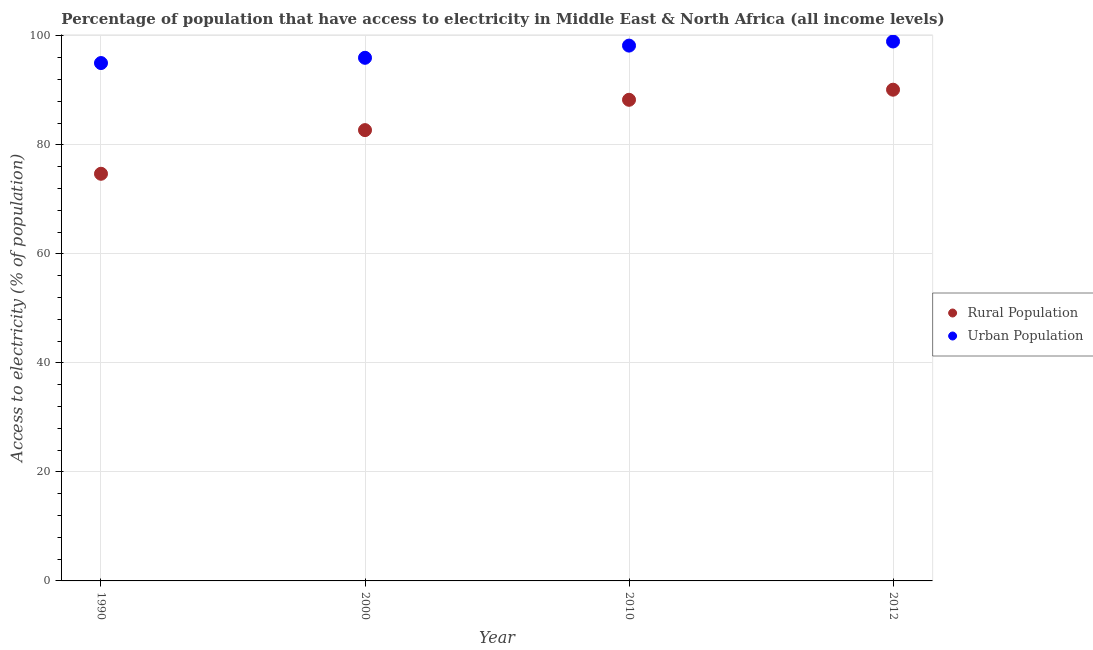How many different coloured dotlines are there?
Your answer should be compact. 2. Is the number of dotlines equal to the number of legend labels?
Provide a succinct answer. Yes. What is the percentage of urban population having access to electricity in 2012?
Offer a terse response. 98.98. Across all years, what is the maximum percentage of rural population having access to electricity?
Provide a short and direct response. 90.14. Across all years, what is the minimum percentage of rural population having access to electricity?
Ensure brevity in your answer.  74.71. In which year was the percentage of urban population having access to electricity maximum?
Keep it short and to the point. 2012. What is the total percentage of urban population having access to electricity in the graph?
Provide a succinct answer. 388.23. What is the difference between the percentage of rural population having access to electricity in 1990 and that in 2012?
Offer a very short reply. -15.43. What is the difference between the percentage of urban population having access to electricity in 2010 and the percentage of rural population having access to electricity in 2012?
Offer a very short reply. 8.09. What is the average percentage of urban population having access to electricity per year?
Give a very brief answer. 97.06. In the year 1990, what is the difference between the percentage of urban population having access to electricity and percentage of rural population having access to electricity?
Offer a terse response. 20.32. What is the ratio of the percentage of rural population having access to electricity in 2000 to that in 2012?
Offer a terse response. 0.92. What is the difference between the highest and the second highest percentage of urban population having access to electricity?
Provide a succinct answer. 0.76. What is the difference between the highest and the lowest percentage of urban population having access to electricity?
Give a very brief answer. 3.96. In how many years, is the percentage of urban population having access to electricity greater than the average percentage of urban population having access to electricity taken over all years?
Keep it short and to the point. 2. Does the percentage of urban population having access to electricity monotonically increase over the years?
Your answer should be compact. Yes. Is the percentage of urban population having access to electricity strictly greater than the percentage of rural population having access to electricity over the years?
Your answer should be compact. Yes. Is the percentage of rural population having access to electricity strictly less than the percentage of urban population having access to electricity over the years?
Your answer should be compact. Yes. What is the difference between two consecutive major ticks on the Y-axis?
Your response must be concise. 20. Are the values on the major ticks of Y-axis written in scientific E-notation?
Offer a terse response. No. Does the graph contain any zero values?
Ensure brevity in your answer.  No. Does the graph contain grids?
Provide a short and direct response. Yes. What is the title of the graph?
Ensure brevity in your answer.  Percentage of population that have access to electricity in Middle East & North Africa (all income levels). Does "Foreign liabilities" appear as one of the legend labels in the graph?
Make the answer very short. No. What is the label or title of the Y-axis?
Your answer should be very brief. Access to electricity (% of population). What is the Access to electricity (% of population) of Rural Population in 1990?
Offer a very short reply. 74.71. What is the Access to electricity (% of population) in Urban Population in 1990?
Your answer should be very brief. 95.03. What is the Access to electricity (% of population) of Rural Population in 2000?
Offer a terse response. 82.72. What is the Access to electricity (% of population) of Urban Population in 2000?
Provide a short and direct response. 95.99. What is the Access to electricity (% of population) in Rural Population in 2010?
Offer a terse response. 88.28. What is the Access to electricity (% of population) in Urban Population in 2010?
Provide a short and direct response. 98.23. What is the Access to electricity (% of population) in Rural Population in 2012?
Keep it short and to the point. 90.14. What is the Access to electricity (% of population) in Urban Population in 2012?
Keep it short and to the point. 98.98. Across all years, what is the maximum Access to electricity (% of population) in Rural Population?
Your response must be concise. 90.14. Across all years, what is the maximum Access to electricity (% of population) in Urban Population?
Give a very brief answer. 98.98. Across all years, what is the minimum Access to electricity (% of population) of Rural Population?
Provide a short and direct response. 74.71. Across all years, what is the minimum Access to electricity (% of population) in Urban Population?
Your response must be concise. 95.03. What is the total Access to electricity (% of population) of Rural Population in the graph?
Provide a short and direct response. 335.85. What is the total Access to electricity (% of population) in Urban Population in the graph?
Provide a short and direct response. 388.23. What is the difference between the Access to electricity (% of population) in Rural Population in 1990 and that in 2000?
Your response must be concise. -8.01. What is the difference between the Access to electricity (% of population) of Urban Population in 1990 and that in 2000?
Keep it short and to the point. -0.96. What is the difference between the Access to electricity (% of population) in Rural Population in 1990 and that in 2010?
Your response must be concise. -13.57. What is the difference between the Access to electricity (% of population) in Urban Population in 1990 and that in 2010?
Offer a very short reply. -3.2. What is the difference between the Access to electricity (% of population) in Rural Population in 1990 and that in 2012?
Your answer should be compact. -15.43. What is the difference between the Access to electricity (% of population) in Urban Population in 1990 and that in 2012?
Ensure brevity in your answer.  -3.96. What is the difference between the Access to electricity (% of population) in Rural Population in 2000 and that in 2010?
Provide a short and direct response. -5.56. What is the difference between the Access to electricity (% of population) of Urban Population in 2000 and that in 2010?
Ensure brevity in your answer.  -2.24. What is the difference between the Access to electricity (% of population) of Rural Population in 2000 and that in 2012?
Your answer should be very brief. -7.42. What is the difference between the Access to electricity (% of population) in Urban Population in 2000 and that in 2012?
Ensure brevity in your answer.  -2.99. What is the difference between the Access to electricity (% of population) of Rural Population in 2010 and that in 2012?
Your answer should be very brief. -1.85. What is the difference between the Access to electricity (% of population) in Urban Population in 2010 and that in 2012?
Provide a succinct answer. -0.76. What is the difference between the Access to electricity (% of population) of Rural Population in 1990 and the Access to electricity (% of population) of Urban Population in 2000?
Provide a succinct answer. -21.28. What is the difference between the Access to electricity (% of population) of Rural Population in 1990 and the Access to electricity (% of population) of Urban Population in 2010?
Your response must be concise. -23.52. What is the difference between the Access to electricity (% of population) in Rural Population in 1990 and the Access to electricity (% of population) in Urban Population in 2012?
Make the answer very short. -24.27. What is the difference between the Access to electricity (% of population) in Rural Population in 2000 and the Access to electricity (% of population) in Urban Population in 2010?
Your answer should be very brief. -15.51. What is the difference between the Access to electricity (% of population) of Rural Population in 2000 and the Access to electricity (% of population) of Urban Population in 2012?
Provide a succinct answer. -16.26. What is the difference between the Access to electricity (% of population) of Rural Population in 2010 and the Access to electricity (% of population) of Urban Population in 2012?
Ensure brevity in your answer.  -10.7. What is the average Access to electricity (% of population) of Rural Population per year?
Your answer should be compact. 83.96. What is the average Access to electricity (% of population) in Urban Population per year?
Provide a short and direct response. 97.06. In the year 1990, what is the difference between the Access to electricity (% of population) of Rural Population and Access to electricity (% of population) of Urban Population?
Provide a short and direct response. -20.32. In the year 2000, what is the difference between the Access to electricity (% of population) of Rural Population and Access to electricity (% of population) of Urban Population?
Your answer should be compact. -13.27. In the year 2010, what is the difference between the Access to electricity (% of population) of Rural Population and Access to electricity (% of population) of Urban Population?
Ensure brevity in your answer.  -9.94. In the year 2012, what is the difference between the Access to electricity (% of population) of Rural Population and Access to electricity (% of population) of Urban Population?
Your answer should be compact. -8.85. What is the ratio of the Access to electricity (% of population) in Rural Population in 1990 to that in 2000?
Keep it short and to the point. 0.9. What is the ratio of the Access to electricity (% of population) of Urban Population in 1990 to that in 2000?
Make the answer very short. 0.99. What is the ratio of the Access to electricity (% of population) in Rural Population in 1990 to that in 2010?
Offer a very short reply. 0.85. What is the ratio of the Access to electricity (% of population) in Urban Population in 1990 to that in 2010?
Ensure brevity in your answer.  0.97. What is the ratio of the Access to electricity (% of population) in Rural Population in 1990 to that in 2012?
Keep it short and to the point. 0.83. What is the ratio of the Access to electricity (% of population) of Urban Population in 1990 to that in 2012?
Give a very brief answer. 0.96. What is the ratio of the Access to electricity (% of population) of Rural Population in 2000 to that in 2010?
Ensure brevity in your answer.  0.94. What is the ratio of the Access to electricity (% of population) in Urban Population in 2000 to that in 2010?
Keep it short and to the point. 0.98. What is the ratio of the Access to electricity (% of population) in Rural Population in 2000 to that in 2012?
Keep it short and to the point. 0.92. What is the ratio of the Access to electricity (% of population) of Urban Population in 2000 to that in 2012?
Make the answer very short. 0.97. What is the ratio of the Access to electricity (% of population) in Rural Population in 2010 to that in 2012?
Give a very brief answer. 0.98. What is the ratio of the Access to electricity (% of population) in Urban Population in 2010 to that in 2012?
Your response must be concise. 0.99. What is the difference between the highest and the second highest Access to electricity (% of population) of Rural Population?
Keep it short and to the point. 1.85. What is the difference between the highest and the second highest Access to electricity (% of population) in Urban Population?
Ensure brevity in your answer.  0.76. What is the difference between the highest and the lowest Access to electricity (% of population) in Rural Population?
Your response must be concise. 15.43. What is the difference between the highest and the lowest Access to electricity (% of population) of Urban Population?
Give a very brief answer. 3.96. 